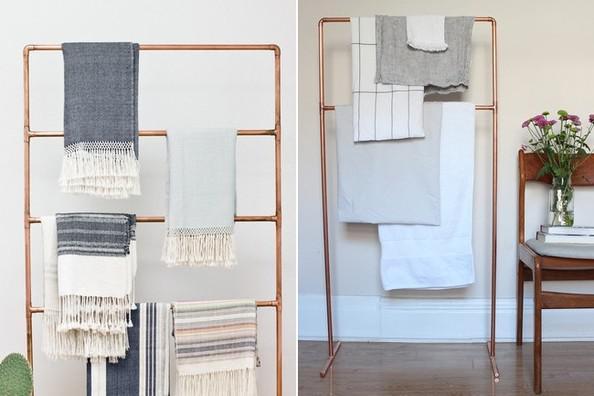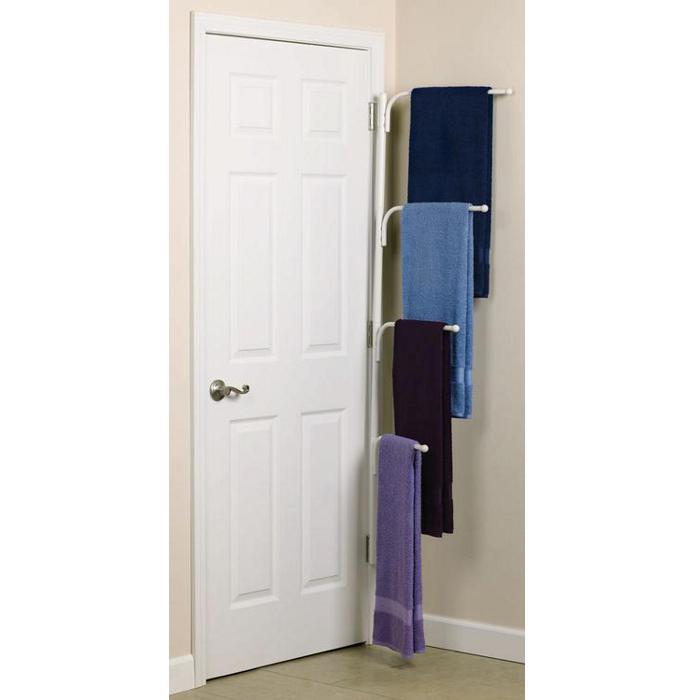The first image is the image on the left, the second image is the image on the right. Considering the images on both sides, is "Exactly two towels hang from hooks in one image." valid? Answer yes or no. No. 